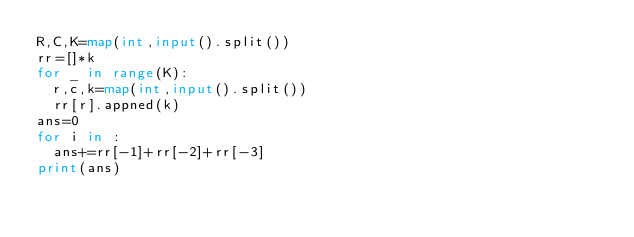<code> <loc_0><loc_0><loc_500><loc_500><_Python_>R,C,K=map(int,input().split())
rr=[]*k
for _ in range(K):
  r,c,k=map(int,input().split())
  rr[r].appned(k)
ans=0
for i in :
  ans+=rr[-1]+rr[-2]+rr[-3]
print(ans)
</code> 